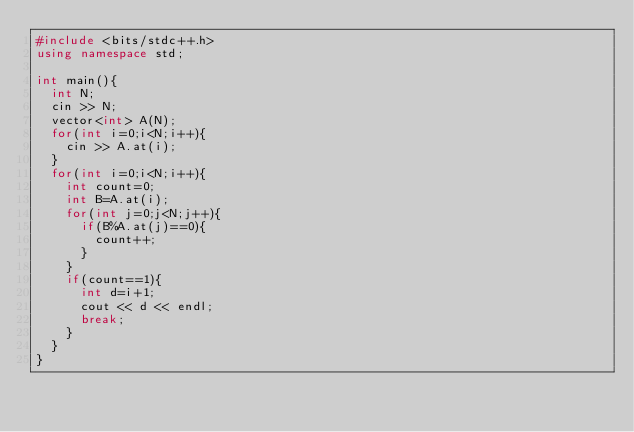Convert code to text. <code><loc_0><loc_0><loc_500><loc_500><_C++_>#include <bits/stdc++.h>
using namespace std;

int main(){
  int N;
  cin >> N;
  vector<int> A(N);
  for(int i=0;i<N;i++){
    cin >> A.at(i);
  }
  for(int i=0;i<N;i++){
    int count=0;
    int B=A.at(i);
    for(int j=0;j<N;j++){
      if(B%A.at(j)==0){
        count++;
      }
    }
    if(count==1){
      int d=i+1;
      cout << d << endl;
      break;
    }
  }
}</code> 